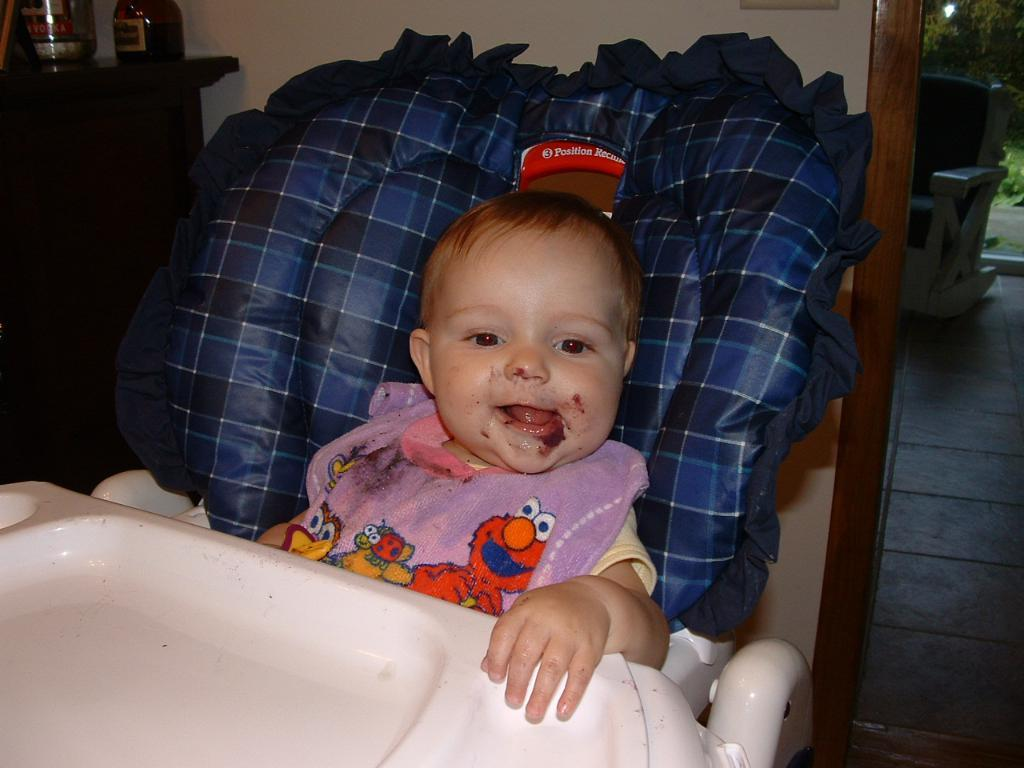What is the main subject of the image? The main subject of the image is a baby. What is the baby doing in the image? The baby is sitting on a chair in the image. What is the baby wearing in the image? The baby is wearing a bib in the image. What grade is the baby in, as depicted in the image? The image does not provide information about the baby's grade, as it is not relevant to the content of the image. 